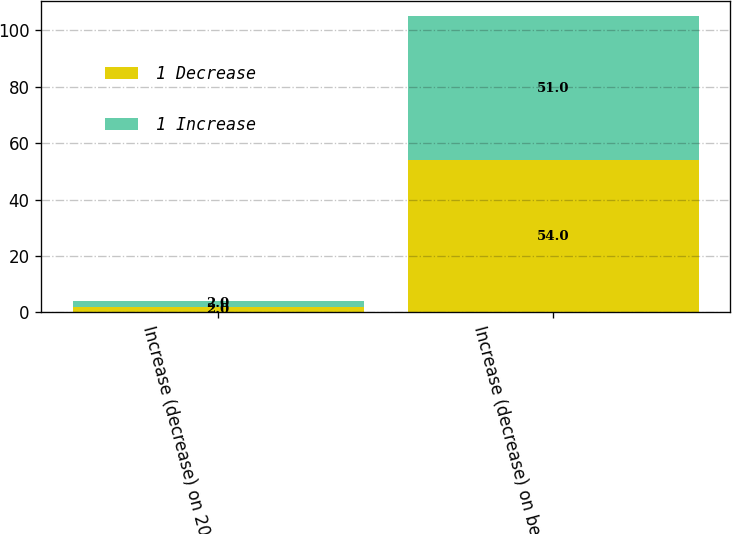Convert chart to OTSL. <chart><loc_0><loc_0><loc_500><loc_500><stacked_bar_chart><ecel><fcel>Increase (decrease) on 2017<fcel>Increase (decrease) on benefit<nl><fcel>1 Decrease<fcel>2<fcel>54<nl><fcel>1 Increase<fcel>2<fcel>51<nl></chart> 